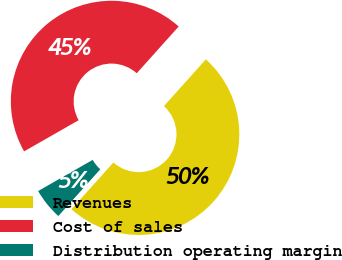Convert chart to OTSL. <chart><loc_0><loc_0><loc_500><loc_500><pie_chart><fcel>Revenues<fcel>Cost of sales<fcel>Distribution operating margin<nl><fcel>50.0%<fcel>44.9%<fcel>5.1%<nl></chart> 